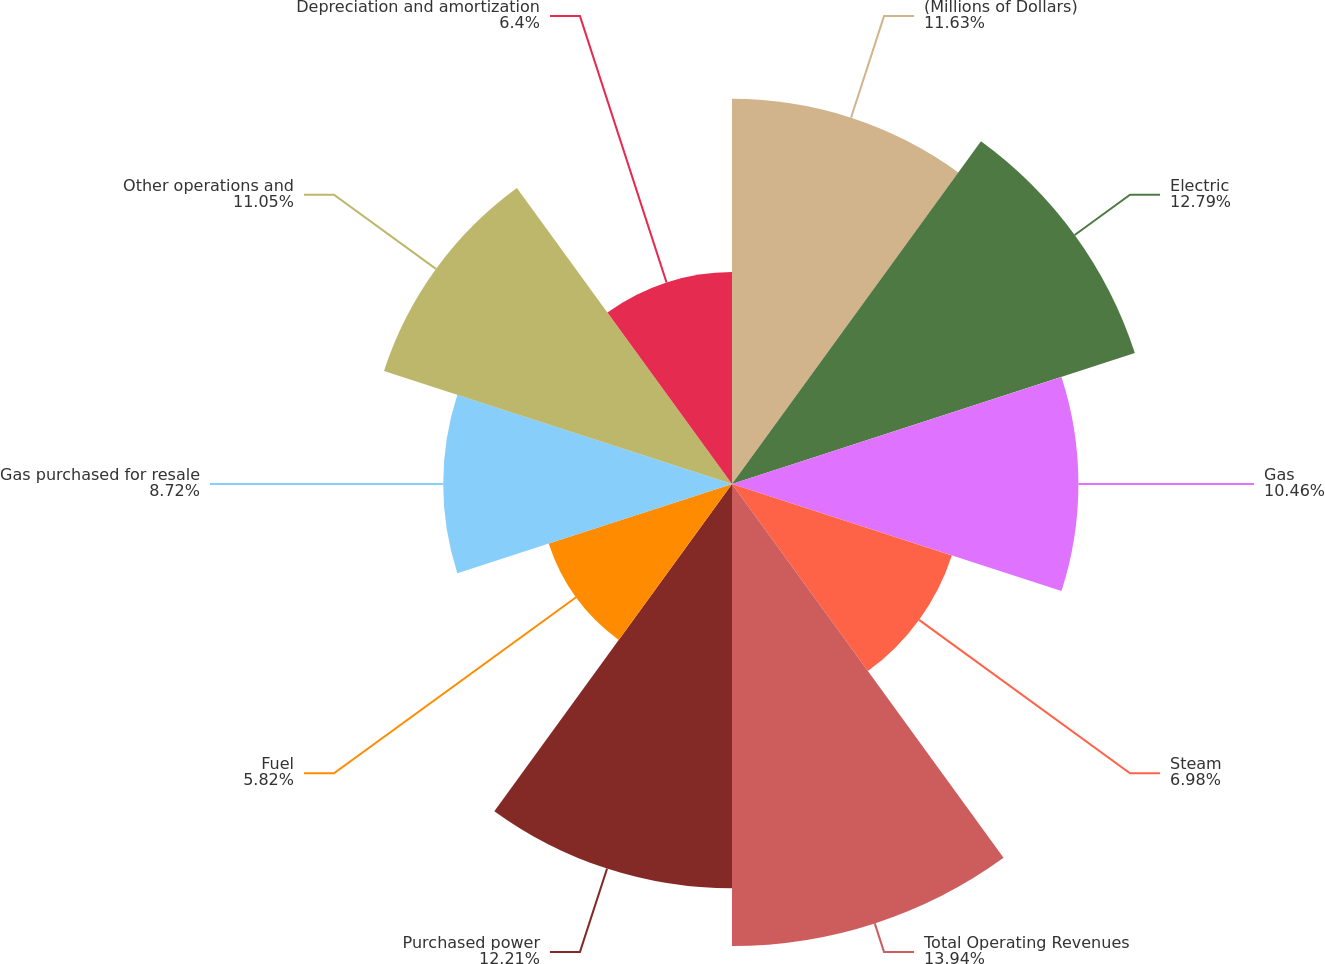Convert chart. <chart><loc_0><loc_0><loc_500><loc_500><pie_chart><fcel>(Millions of Dollars)<fcel>Electric<fcel>Gas<fcel>Steam<fcel>Total Operating Revenues<fcel>Purchased power<fcel>Fuel<fcel>Gas purchased for resale<fcel>Other operations and<fcel>Depreciation and amortization<nl><fcel>11.63%<fcel>12.79%<fcel>10.46%<fcel>6.98%<fcel>13.95%<fcel>12.21%<fcel>5.82%<fcel>8.72%<fcel>11.05%<fcel>6.4%<nl></chart> 